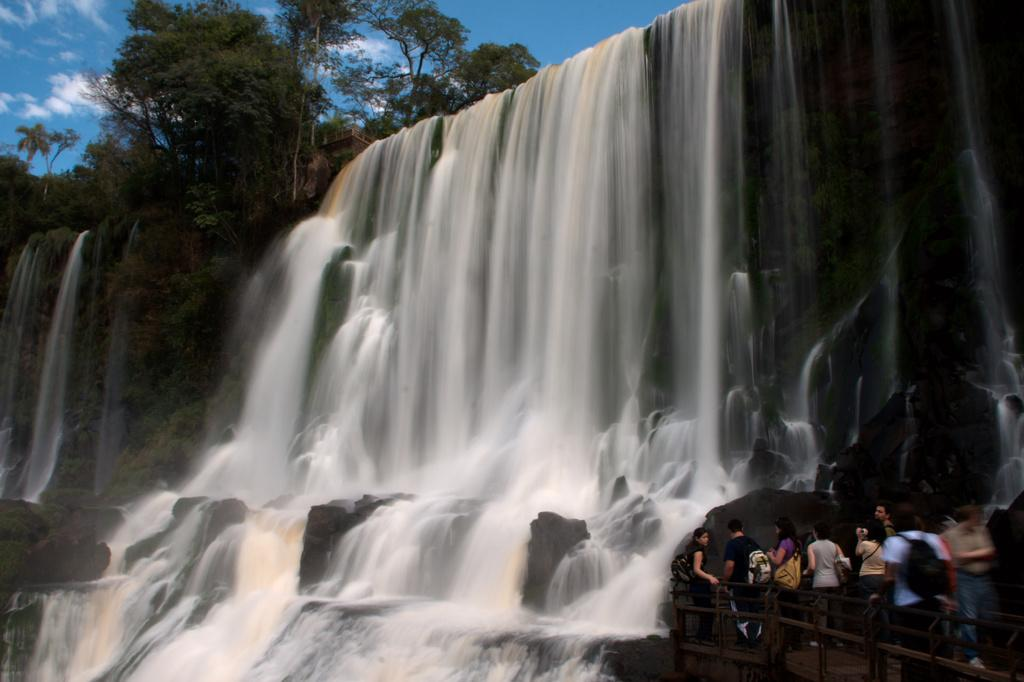What natural feature is the main subject of the image? There is a waterfall in the image. What man-made structure can be seen in the image? There is a bridge in the bottom right of the image. Who or what is on the bridge? There are people on the bridge. What type of vegetation is visible in the image? There are trees in the top left of the image. What is the color of the sky in the image? The sky is blue in the image. What is the main plot of the amusement park in the image? There is no amusement park present in the image; it features a waterfall, a bridge, and trees. How does the self-awareness of the trees impact the image? The trees in the image do not have self-awareness, as they are inanimate objects. 